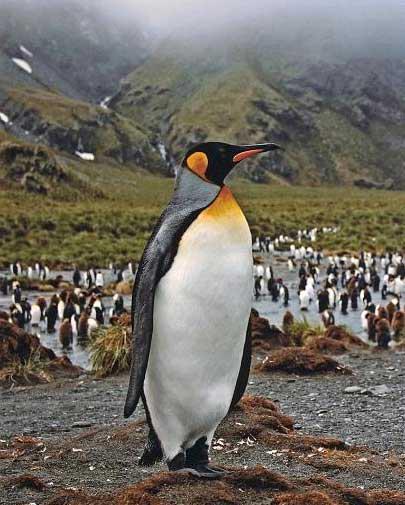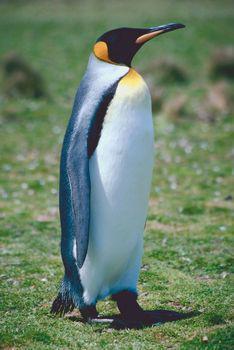The first image is the image on the left, the second image is the image on the right. Examine the images to the left and right. Is the description "There are two penguins in the right image." accurate? Answer yes or no. No. The first image is the image on the left, the second image is the image on the right. Considering the images on both sides, is "An image shows exactly two penguins who appear to be walking """"hand-in-hand""""." valid? Answer yes or no. No. 